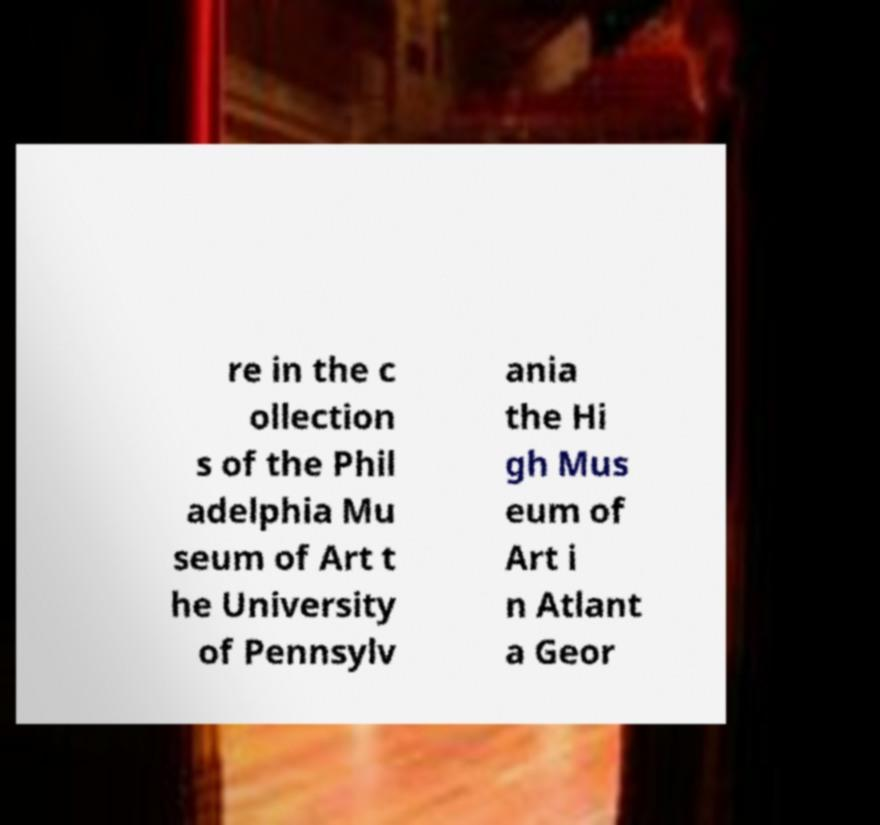I need the written content from this picture converted into text. Can you do that? re in the c ollection s of the Phil adelphia Mu seum of Art t he University of Pennsylv ania the Hi gh Mus eum of Art i n Atlant a Geor 